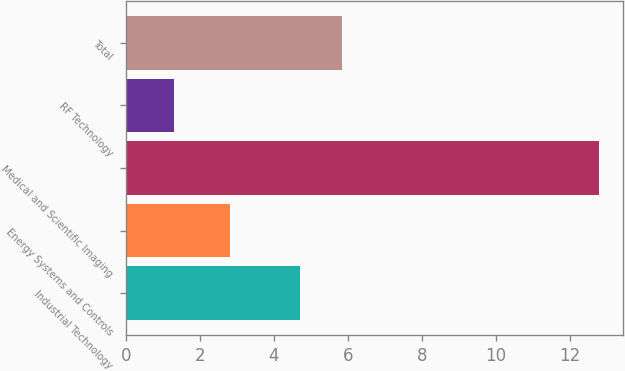<chart> <loc_0><loc_0><loc_500><loc_500><bar_chart><fcel>Industrial Technology<fcel>Energy Systems and Controls<fcel>Medical and Scientific Imaging<fcel>RF Technology<fcel>Total<nl><fcel>4.7<fcel>2.8<fcel>12.8<fcel>1.3<fcel>5.85<nl></chart> 